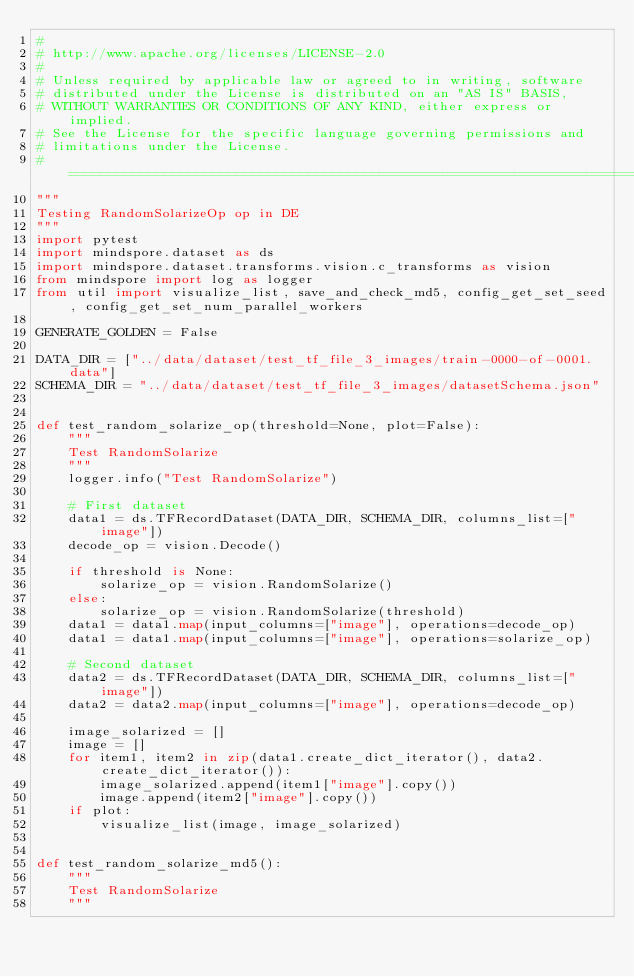<code> <loc_0><loc_0><loc_500><loc_500><_Python_>#
# http://www.apache.org/licenses/LICENSE-2.0
#
# Unless required by applicable law or agreed to in writing, software
# distributed under the License is distributed on an "AS IS" BASIS,
# WITHOUT WARRANTIES OR CONDITIONS OF ANY KIND, either express or implied.
# See the License for the specific language governing permissions and
# limitations under the License.
# ==============================================================================
"""
Testing RandomSolarizeOp op in DE
"""
import pytest
import mindspore.dataset as ds
import mindspore.dataset.transforms.vision.c_transforms as vision
from mindspore import log as logger
from util import visualize_list, save_and_check_md5, config_get_set_seed, config_get_set_num_parallel_workers

GENERATE_GOLDEN = False

DATA_DIR = ["../data/dataset/test_tf_file_3_images/train-0000-of-0001.data"]
SCHEMA_DIR = "../data/dataset/test_tf_file_3_images/datasetSchema.json"


def test_random_solarize_op(threshold=None, plot=False):
    """
    Test RandomSolarize
    """
    logger.info("Test RandomSolarize")

    # First dataset
    data1 = ds.TFRecordDataset(DATA_DIR, SCHEMA_DIR, columns_list=["image"])
    decode_op = vision.Decode()

    if threshold is None:
        solarize_op = vision.RandomSolarize()
    else:
        solarize_op = vision.RandomSolarize(threshold)
    data1 = data1.map(input_columns=["image"], operations=decode_op)
    data1 = data1.map(input_columns=["image"], operations=solarize_op)

    # Second dataset
    data2 = ds.TFRecordDataset(DATA_DIR, SCHEMA_DIR, columns_list=["image"])
    data2 = data2.map(input_columns=["image"], operations=decode_op)

    image_solarized = []
    image = []
    for item1, item2 in zip(data1.create_dict_iterator(), data2.create_dict_iterator()):
        image_solarized.append(item1["image"].copy())
        image.append(item2["image"].copy())
    if plot:
        visualize_list(image, image_solarized)


def test_random_solarize_md5():
    """
    Test RandomSolarize
    """</code> 